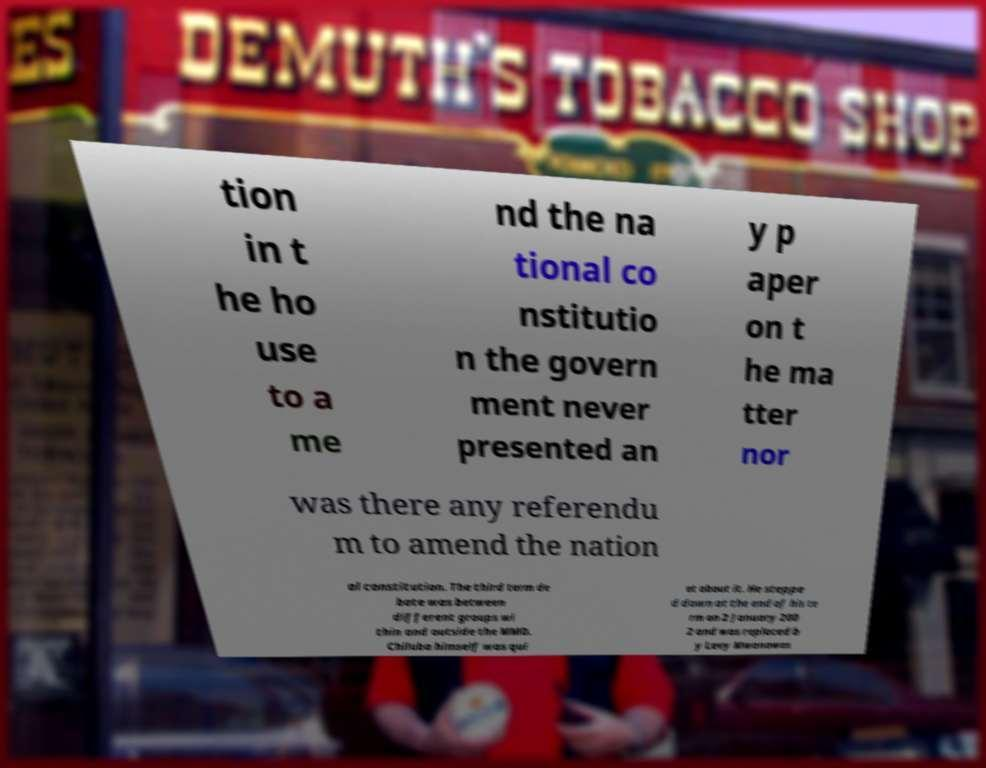Could you assist in decoding the text presented in this image and type it out clearly? tion in t he ho use to a me nd the na tional co nstitutio n the govern ment never presented an y p aper on t he ma tter nor was there any referendu m to amend the nation al constitution. The third term de bate was between different groups wi thin and outside the MMD. Chiluba himself was qui et about it. He steppe d down at the end of his te rm on 2 January 200 2 and was replaced b y Levy Mwanawas 